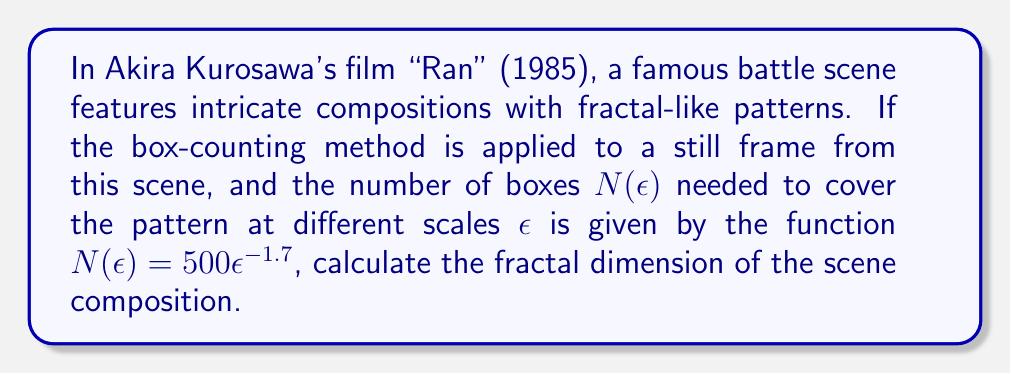Solve this math problem. To calculate the fractal dimension using the box-counting method, we follow these steps:

1. The general form of the box-counting function is:
   $$N(\epsilon) = C\epsilon^{-D}$$
   where $C$ is a constant, $\epsilon$ is the scale, and $D$ is the fractal dimension.

2. In our case, we have:
   $$N(\epsilon) = 500\epsilon^{-1.7}$$

3. Comparing this to the general form, we can see that:
   $C = 500$
   $D = 1.7$

4. The fractal dimension $D$ is the exponent in the box-counting function, which in this case is 1.7.

5. This value (1.7) lies between 1 and 2, which is typical for fractal patterns in 2D images. It suggests that the scene composition has more complexity than a simple line (dimension 1) but less than a fully filled 2D plane (dimension 2).
Answer: $D = 1.7$ 